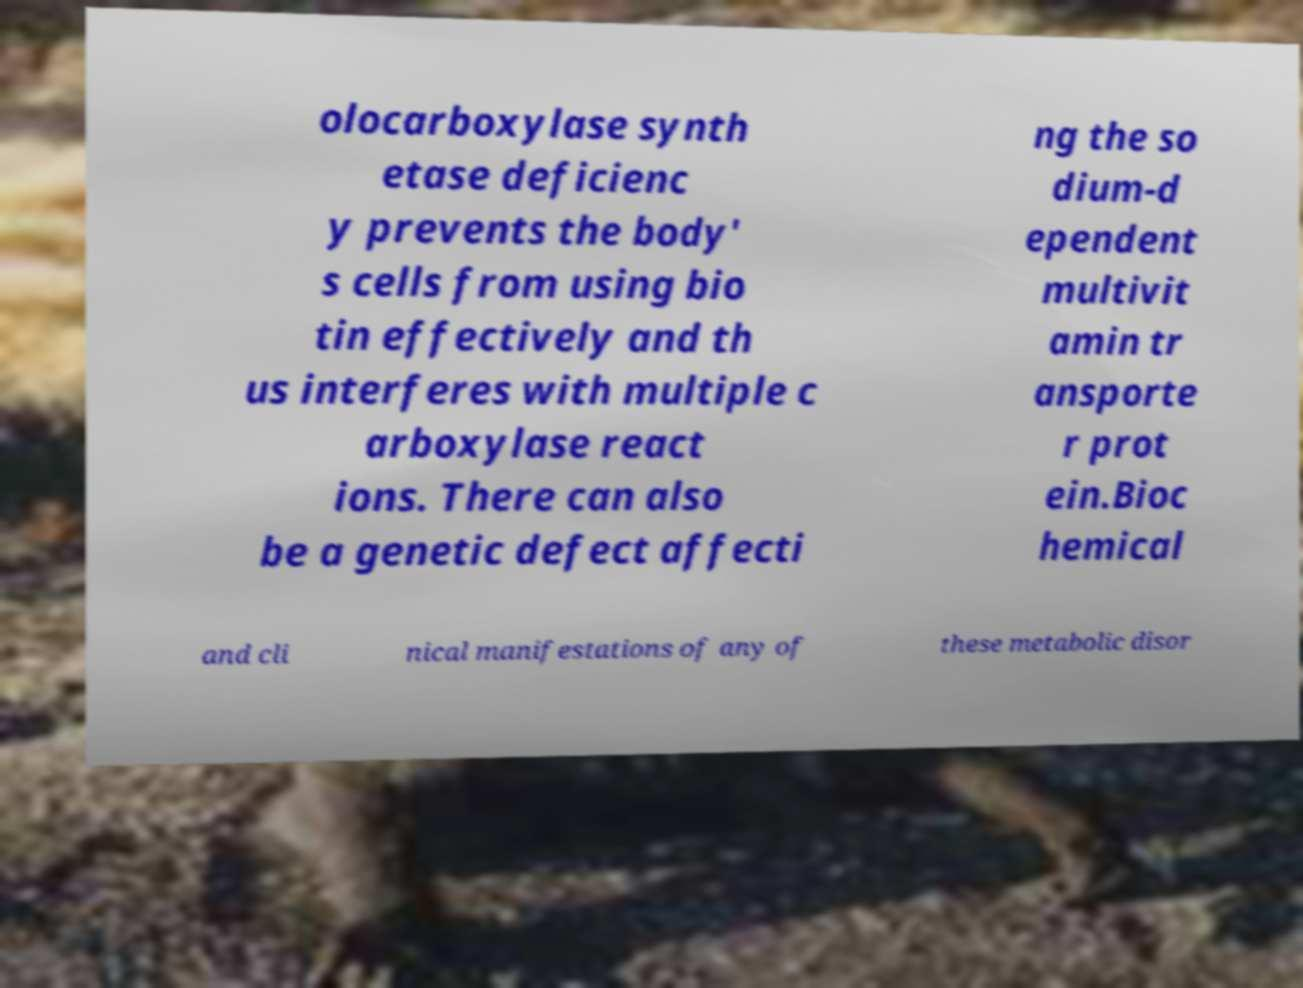Can you read and provide the text displayed in the image?This photo seems to have some interesting text. Can you extract and type it out for me? olocarboxylase synth etase deficienc y prevents the body' s cells from using bio tin effectively and th us interferes with multiple c arboxylase react ions. There can also be a genetic defect affecti ng the so dium-d ependent multivit amin tr ansporte r prot ein.Bioc hemical and cli nical manifestations of any of these metabolic disor 